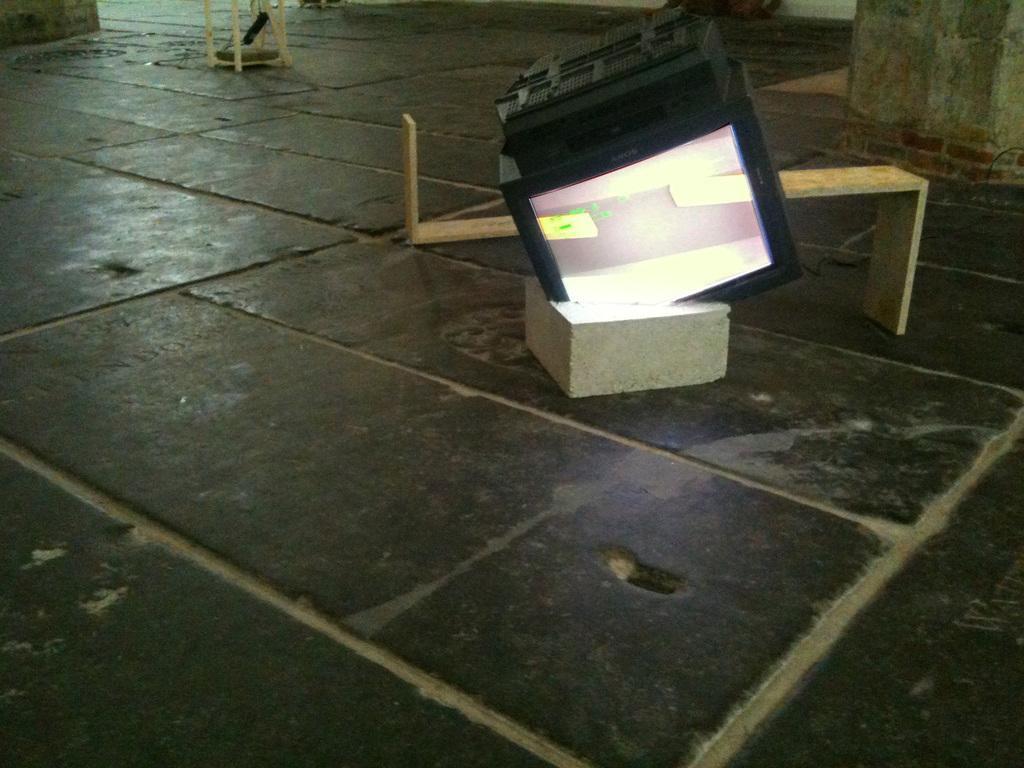Please provide a concise description of this image. In this image there is a floor, on that floor there is a box, on that box there is a monitor, in the background there are wooden sticks and pillars. 